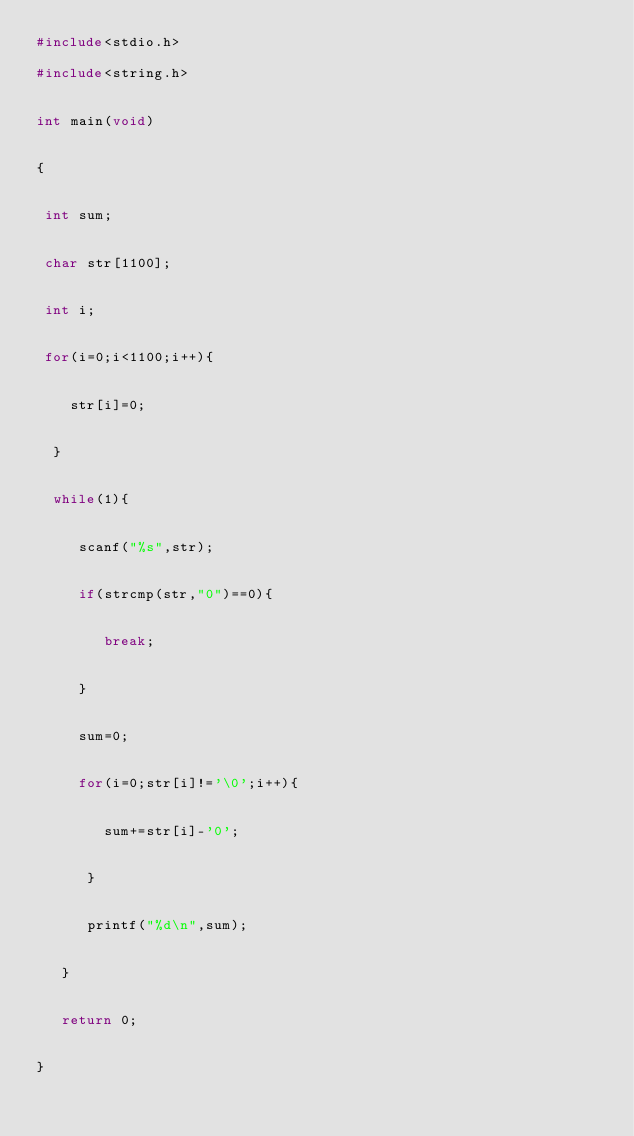Convert code to text. <code><loc_0><loc_0><loc_500><loc_500><_C_>#include<stdio.h>

#include<string.h>


int main(void)


{


 int sum;


 char str[1100];


 int i;


 for(i=0;i<1100;i++){


    str[i]=0;


  }


  while(1){


     scanf("%s",str);


     if(strcmp(str,"0")==0){


        break;


     }


     sum=0;


     for(i=0;str[i]!='\0';i++){


        sum+=str[i]-'0';


      }


      printf("%d\n",sum);


   }


   return 0;


}</code> 